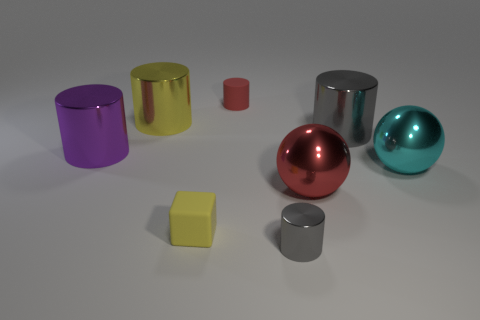Subtract 1 cylinders. How many cylinders are left? 4 Subtract all red cylinders. How many cylinders are left? 4 Subtract all yellow metal cylinders. How many cylinders are left? 4 Subtract all brown cylinders. Subtract all brown spheres. How many cylinders are left? 5 Add 2 tiny yellow rubber objects. How many objects exist? 10 Subtract all cylinders. How many objects are left? 3 Subtract 0 blue cubes. How many objects are left? 8 Subtract all tiny green metallic blocks. Subtract all big gray metal cylinders. How many objects are left? 7 Add 7 red things. How many red things are left? 9 Add 6 large cyan balls. How many large cyan balls exist? 7 